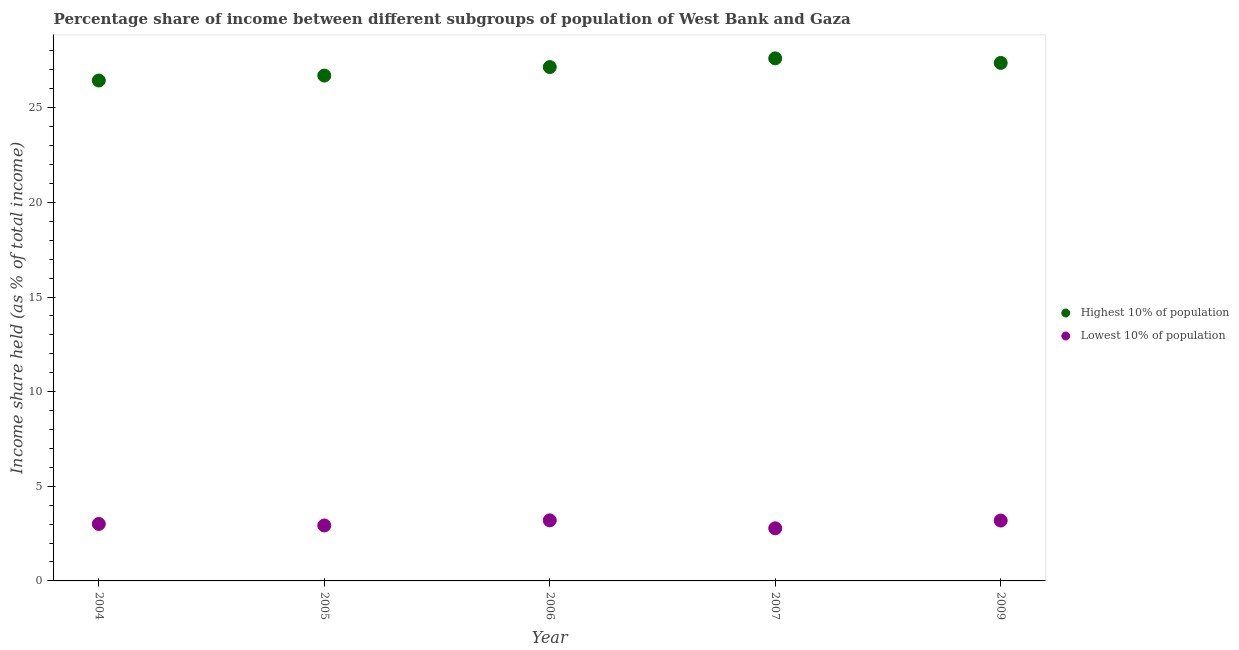How many different coloured dotlines are there?
Your answer should be compact. 2. What is the income share held by lowest 10% of the population in 2009?
Keep it short and to the point. 3.19. Across all years, what is the minimum income share held by highest 10% of the population?
Provide a succinct answer. 26.44. In which year was the income share held by highest 10% of the population minimum?
Ensure brevity in your answer.  2004. What is the total income share held by highest 10% of the population in the graph?
Make the answer very short. 135.27. What is the difference between the income share held by lowest 10% of the population in 2006 and that in 2007?
Make the answer very short. 0.42. What is the difference between the income share held by highest 10% of the population in 2007 and the income share held by lowest 10% of the population in 2004?
Provide a succinct answer. 24.6. What is the average income share held by lowest 10% of the population per year?
Offer a terse response. 3.02. In the year 2006, what is the difference between the income share held by lowest 10% of the population and income share held by highest 10% of the population?
Your answer should be compact. -23.95. In how many years, is the income share held by highest 10% of the population greater than 11 %?
Your answer should be very brief. 5. What is the ratio of the income share held by lowest 10% of the population in 2006 to that in 2009?
Your answer should be compact. 1. What is the difference between the highest and the second highest income share held by highest 10% of the population?
Provide a short and direct response. 0.24. What is the difference between the highest and the lowest income share held by lowest 10% of the population?
Provide a short and direct response. 0.42. Does the income share held by highest 10% of the population monotonically increase over the years?
Your answer should be very brief. No. Is the income share held by lowest 10% of the population strictly less than the income share held by highest 10% of the population over the years?
Ensure brevity in your answer.  Yes. How many dotlines are there?
Keep it short and to the point. 2. How many years are there in the graph?
Offer a terse response. 5. What is the difference between two consecutive major ticks on the Y-axis?
Your answer should be very brief. 5. Are the values on the major ticks of Y-axis written in scientific E-notation?
Your response must be concise. No. Where does the legend appear in the graph?
Give a very brief answer. Center right. How many legend labels are there?
Ensure brevity in your answer.  2. What is the title of the graph?
Provide a succinct answer. Percentage share of income between different subgroups of population of West Bank and Gaza. Does "Domestic liabilities" appear as one of the legend labels in the graph?
Provide a succinct answer. No. What is the label or title of the Y-axis?
Ensure brevity in your answer.  Income share held (as % of total income). What is the Income share held (as % of total income) of Highest 10% of population in 2004?
Make the answer very short. 26.44. What is the Income share held (as % of total income) in Lowest 10% of population in 2004?
Your answer should be compact. 3.01. What is the Income share held (as % of total income) of Highest 10% of population in 2005?
Give a very brief answer. 26.7. What is the Income share held (as % of total income) in Lowest 10% of population in 2005?
Your answer should be compact. 2.93. What is the Income share held (as % of total income) of Highest 10% of population in 2006?
Provide a short and direct response. 27.15. What is the Income share held (as % of total income) in Lowest 10% of population in 2006?
Provide a short and direct response. 3.2. What is the Income share held (as % of total income) of Highest 10% of population in 2007?
Your answer should be compact. 27.61. What is the Income share held (as % of total income) of Lowest 10% of population in 2007?
Give a very brief answer. 2.78. What is the Income share held (as % of total income) in Highest 10% of population in 2009?
Your answer should be very brief. 27.37. What is the Income share held (as % of total income) in Lowest 10% of population in 2009?
Provide a succinct answer. 3.19. Across all years, what is the maximum Income share held (as % of total income) in Highest 10% of population?
Make the answer very short. 27.61. Across all years, what is the maximum Income share held (as % of total income) in Lowest 10% of population?
Offer a very short reply. 3.2. Across all years, what is the minimum Income share held (as % of total income) of Highest 10% of population?
Your response must be concise. 26.44. Across all years, what is the minimum Income share held (as % of total income) in Lowest 10% of population?
Keep it short and to the point. 2.78. What is the total Income share held (as % of total income) of Highest 10% of population in the graph?
Offer a very short reply. 135.27. What is the total Income share held (as % of total income) of Lowest 10% of population in the graph?
Make the answer very short. 15.11. What is the difference between the Income share held (as % of total income) of Highest 10% of population in 2004 and that in 2005?
Give a very brief answer. -0.26. What is the difference between the Income share held (as % of total income) of Lowest 10% of population in 2004 and that in 2005?
Your answer should be compact. 0.08. What is the difference between the Income share held (as % of total income) of Highest 10% of population in 2004 and that in 2006?
Ensure brevity in your answer.  -0.71. What is the difference between the Income share held (as % of total income) in Lowest 10% of population in 2004 and that in 2006?
Make the answer very short. -0.19. What is the difference between the Income share held (as % of total income) in Highest 10% of population in 2004 and that in 2007?
Provide a short and direct response. -1.17. What is the difference between the Income share held (as % of total income) of Lowest 10% of population in 2004 and that in 2007?
Offer a very short reply. 0.23. What is the difference between the Income share held (as % of total income) of Highest 10% of population in 2004 and that in 2009?
Offer a terse response. -0.93. What is the difference between the Income share held (as % of total income) in Lowest 10% of population in 2004 and that in 2009?
Your answer should be compact. -0.18. What is the difference between the Income share held (as % of total income) in Highest 10% of population in 2005 and that in 2006?
Keep it short and to the point. -0.45. What is the difference between the Income share held (as % of total income) of Lowest 10% of population in 2005 and that in 2006?
Your answer should be compact. -0.27. What is the difference between the Income share held (as % of total income) in Highest 10% of population in 2005 and that in 2007?
Provide a succinct answer. -0.91. What is the difference between the Income share held (as % of total income) in Lowest 10% of population in 2005 and that in 2007?
Keep it short and to the point. 0.15. What is the difference between the Income share held (as % of total income) in Highest 10% of population in 2005 and that in 2009?
Make the answer very short. -0.67. What is the difference between the Income share held (as % of total income) in Lowest 10% of population in 2005 and that in 2009?
Provide a short and direct response. -0.26. What is the difference between the Income share held (as % of total income) in Highest 10% of population in 2006 and that in 2007?
Keep it short and to the point. -0.46. What is the difference between the Income share held (as % of total income) of Lowest 10% of population in 2006 and that in 2007?
Your answer should be compact. 0.42. What is the difference between the Income share held (as % of total income) of Highest 10% of population in 2006 and that in 2009?
Ensure brevity in your answer.  -0.22. What is the difference between the Income share held (as % of total income) of Lowest 10% of population in 2006 and that in 2009?
Provide a succinct answer. 0.01. What is the difference between the Income share held (as % of total income) of Highest 10% of population in 2007 and that in 2009?
Offer a terse response. 0.24. What is the difference between the Income share held (as % of total income) of Lowest 10% of population in 2007 and that in 2009?
Ensure brevity in your answer.  -0.41. What is the difference between the Income share held (as % of total income) of Highest 10% of population in 2004 and the Income share held (as % of total income) of Lowest 10% of population in 2005?
Provide a short and direct response. 23.51. What is the difference between the Income share held (as % of total income) in Highest 10% of population in 2004 and the Income share held (as % of total income) in Lowest 10% of population in 2006?
Provide a succinct answer. 23.24. What is the difference between the Income share held (as % of total income) of Highest 10% of population in 2004 and the Income share held (as % of total income) of Lowest 10% of population in 2007?
Offer a very short reply. 23.66. What is the difference between the Income share held (as % of total income) in Highest 10% of population in 2004 and the Income share held (as % of total income) in Lowest 10% of population in 2009?
Keep it short and to the point. 23.25. What is the difference between the Income share held (as % of total income) in Highest 10% of population in 2005 and the Income share held (as % of total income) in Lowest 10% of population in 2006?
Offer a terse response. 23.5. What is the difference between the Income share held (as % of total income) in Highest 10% of population in 2005 and the Income share held (as % of total income) in Lowest 10% of population in 2007?
Give a very brief answer. 23.92. What is the difference between the Income share held (as % of total income) of Highest 10% of population in 2005 and the Income share held (as % of total income) of Lowest 10% of population in 2009?
Your response must be concise. 23.51. What is the difference between the Income share held (as % of total income) in Highest 10% of population in 2006 and the Income share held (as % of total income) in Lowest 10% of population in 2007?
Keep it short and to the point. 24.37. What is the difference between the Income share held (as % of total income) of Highest 10% of population in 2006 and the Income share held (as % of total income) of Lowest 10% of population in 2009?
Offer a very short reply. 23.96. What is the difference between the Income share held (as % of total income) of Highest 10% of population in 2007 and the Income share held (as % of total income) of Lowest 10% of population in 2009?
Your answer should be very brief. 24.42. What is the average Income share held (as % of total income) in Highest 10% of population per year?
Offer a terse response. 27.05. What is the average Income share held (as % of total income) in Lowest 10% of population per year?
Offer a very short reply. 3.02. In the year 2004, what is the difference between the Income share held (as % of total income) of Highest 10% of population and Income share held (as % of total income) of Lowest 10% of population?
Ensure brevity in your answer.  23.43. In the year 2005, what is the difference between the Income share held (as % of total income) of Highest 10% of population and Income share held (as % of total income) of Lowest 10% of population?
Keep it short and to the point. 23.77. In the year 2006, what is the difference between the Income share held (as % of total income) of Highest 10% of population and Income share held (as % of total income) of Lowest 10% of population?
Your answer should be very brief. 23.95. In the year 2007, what is the difference between the Income share held (as % of total income) in Highest 10% of population and Income share held (as % of total income) in Lowest 10% of population?
Make the answer very short. 24.83. In the year 2009, what is the difference between the Income share held (as % of total income) in Highest 10% of population and Income share held (as % of total income) in Lowest 10% of population?
Make the answer very short. 24.18. What is the ratio of the Income share held (as % of total income) of Highest 10% of population in 2004 to that in 2005?
Your answer should be compact. 0.99. What is the ratio of the Income share held (as % of total income) in Lowest 10% of population in 2004 to that in 2005?
Give a very brief answer. 1.03. What is the ratio of the Income share held (as % of total income) in Highest 10% of population in 2004 to that in 2006?
Make the answer very short. 0.97. What is the ratio of the Income share held (as % of total income) of Lowest 10% of population in 2004 to that in 2006?
Ensure brevity in your answer.  0.94. What is the ratio of the Income share held (as % of total income) of Highest 10% of population in 2004 to that in 2007?
Provide a succinct answer. 0.96. What is the ratio of the Income share held (as % of total income) in Lowest 10% of population in 2004 to that in 2007?
Ensure brevity in your answer.  1.08. What is the ratio of the Income share held (as % of total income) in Highest 10% of population in 2004 to that in 2009?
Give a very brief answer. 0.97. What is the ratio of the Income share held (as % of total income) of Lowest 10% of population in 2004 to that in 2009?
Your response must be concise. 0.94. What is the ratio of the Income share held (as % of total income) of Highest 10% of population in 2005 to that in 2006?
Your answer should be compact. 0.98. What is the ratio of the Income share held (as % of total income) of Lowest 10% of population in 2005 to that in 2006?
Your response must be concise. 0.92. What is the ratio of the Income share held (as % of total income) of Highest 10% of population in 2005 to that in 2007?
Your response must be concise. 0.97. What is the ratio of the Income share held (as % of total income) in Lowest 10% of population in 2005 to that in 2007?
Provide a short and direct response. 1.05. What is the ratio of the Income share held (as % of total income) in Highest 10% of population in 2005 to that in 2009?
Ensure brevity in your answer.  0.98. What is the ratio of the Income share held (as % of total income) of Lowest 10% of population in 2005 to that in 2009?
Give a very brief answer. 0.92. What is the ratio of the Income share held (as % of total income) in Highest 10% of population in 2006 to that in 2007?
Your answer should be very brief. 0.98. What is the ratio of the Income share held (as % of total income) of Lowest 10% of population in 2006 to that in 2007?
Offer a terse response. 1.15. What is the ratio of the Income share held (as % of total income) in Highest 10% of population in 2006 to that in 2009?
Your answer should be very brief. 0.99. What is the ratio of the Income share held (as % of total income) in Lowest 10% of population in 2006 to that in 2009?
Your answer should be compact. 1. What is the ratio of the Income share held (as % of total income) of Highest 10% of population in 2007 to that in 2009?
Your answer should be very brief. 1.01. What is the ratio of the Income share held (as % of total income) in Lowest 10% of population in 2007 to that in 2009?
Your response must be concise. 0.87. What is the difference between the highest and the second highest Income share held (as % of total income) of Highest 10% of population?
Offer a very short reply. 0.24. What is the difference between the highest and the lowest Income share held (as % of total income) of Highest 10% of population?
Your response must be concise. 1.17. What is the difference between the highest and the lowest Income share held (as % of total income) of Lowest 10% of population?
Your response must be concise. 0.42. 